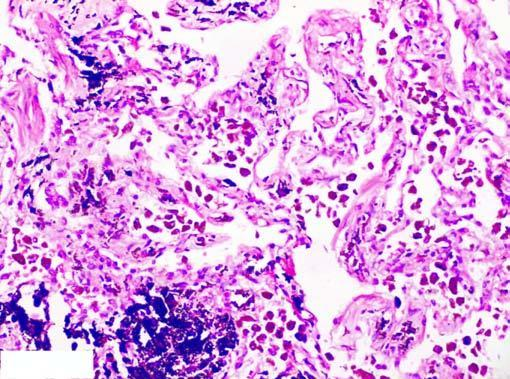where is presence of abundant coarse black carbon pigment?
Answer the question using a single word or phrase. In the septal walls and around the bronchiole 